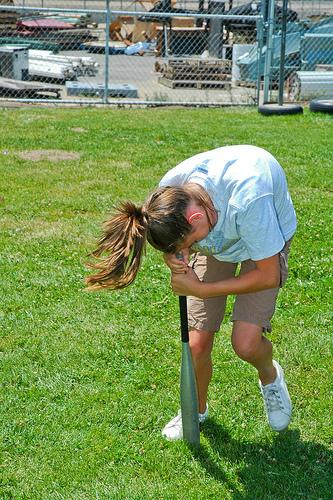Illustrate the central activity and the primary individual performing it, as well as any remarkable items in the picture. A girl with her hair in a ponytail is holding a green baseball bat with a black handle near her face, while standing near a fence with pallets and tires nearby. Pinpoint the primary individual in the photo and the action they are engaging in, also mentioning any significant surroundings. A woman in light brown shorts and a gray shirt holds a baseball bat to her forehead, with a shadow on the grass and a chainlink fence in the backdrop. Describe the central figure in the frame and the action occurring, taking into account any noteworthy objects within the scene. A ponytailed girl is gripping a baseball bat close to her face, clad in a gray and yellow designed t-shirt and white shoes, with a shadow in the grass beside her. Provide a brief description of the primary individual and their activity in the picture. A girl with a ponytail is holding a silver and black baseball bat to her forehead while wearing white sneakers and a gray t-shirt. Explain the image's primary focus alongside the main subject, including notable items or areas. A girl with her hair pulled into a ponytail grips a baseball bat near her forehead while standing on a patch of grass with a background chainlink fence and stacked wooden pallets. Narrate the central subject and action taking place in the image, also addressing any prominent surrounding objects. The image showcases a ponytailed girl holding a silver and black baseball bat to her forehead, wearing white sneakers and standing on grass, with a chainlink fence and piles of trash behind her. Identify the main person in the image and describe what they are doing along with any notable objects around them. A girl with a ponytail in a t-shirt and khakis is holding a baseball bat to her forehead, surrounded by grass and a chainlink fence, with spare tires and stacked pallets in the background. Express the main focus of the image and any notable items within the scene. The image features a woman holding a metal baseball bat, wearing white shoes with white laces, and surrounded by grass with a chainlink fence in the background. Summarize the key elements of the picture and the action taking place. A girl in a gray t-shirt and white sneakers is bent over a silver baseball bat, with her ponytail hanging to the side, in a field with grass and chainlink fence visible. Mention the most important subject and their activity in the image. The picture captures a woman gripping a metal baseball bat while wearing white shoes, standing on grass with a chainlink fence and scattered objects behind her. 